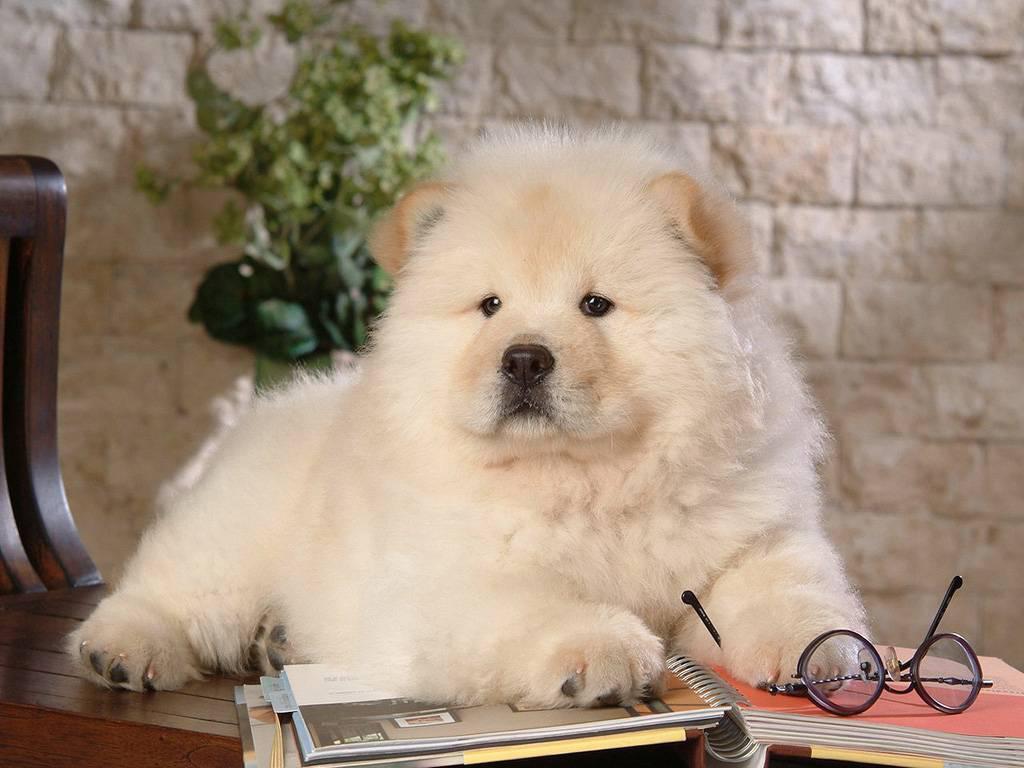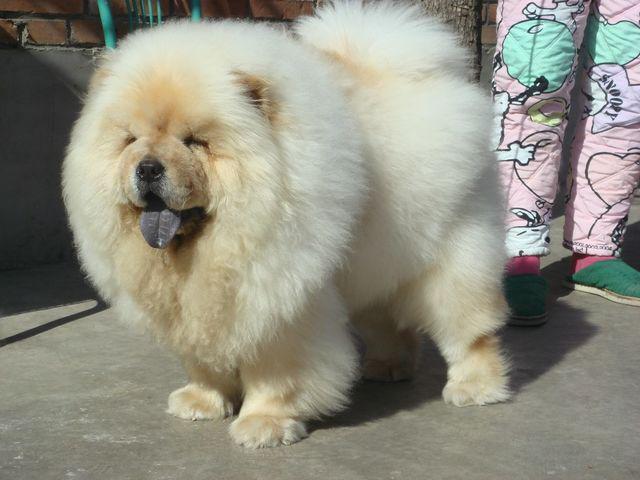The first image is the image on the left, the second image is the image on the right. Assess this claim about the two images: "A chow dog is standing on all fours on a grayish hard surface, with its body turned leftward.". Correct or not? Answer yes or no. Yes. The first image is the image on the left, the second image is the image on the right. Analyze the images presented: Is the assertion "The dog in the image on the right is in the grass." valid? Answer yes or no. No. 